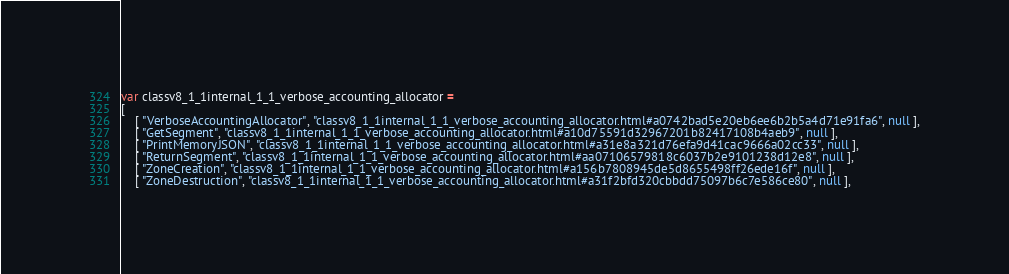<code> <loc_0><loc_0><loc_500><loc_500><_JavaScript_>var classv8_1_1internal_1_1_verbose_accounting_allocator =
[
    [ "VerboseAccountingAllocator", "classv8_1_1internal_1_1_verbose_accounting_allocator.html#a0742bad5e20eb6ee6b2b5a4d71e91fa6", null ],
    [ "GetSegment", "classv8_1_1internal_1_1_verbose_accounting_allocator.html#a10d75591d32967201b82417108b4aeb9", null ],
    [ "PrintMemoryJSON", "classv8_1_1internal_1_1_verbose_accounting_allocator.html#a31e8a321d76efa9d41cac9666a02cc33", null ],
    [ "ReturnSegment", "classv8_1_1internal_1_1_verbose_accounting_allocator.html#aa07106579818c6037b2e9101238d12e8", null ],
    [ "ZoneCreation", "classv8_1_1internal_1_1_verbose_accounting_allocator.html#a156b7808945de5d8655498ff26ede16f", null ],
    [ "ZoneDestruction", "classv8_1_1internal_1_1_verbose_accounting_allocator.html#a31f2bfd320cbbdd75097b6c7e586ce80", null ],</code> 